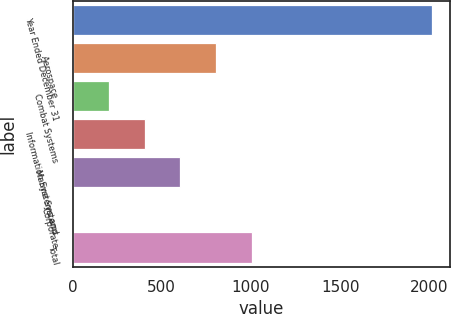Convert chart. <chart><loc_0><loc_0><loc_500><loc_500><bar_chart><fcel>Year Ended December 31<fcel>Aerospace<fcel>Combat Systems<fcel>Information Systems and<fcel>Marine Systems<fcel>Corporate<fcel>Total<nl><fcel>2013<fcel>805.8<fcel>202.2<fcel>403.4<fcel>604.6<fcel>1<fcel>1007<nl></chart> 